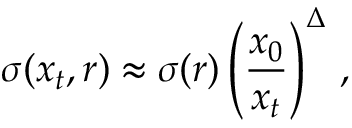<formula> <loc_0><loc_0><loc_500><loc_500>\sigma ( x _ { t } , r ) \approx \sigma ( r ) \left ( { \frac { x _ { 0 } } { x _ { t } } } \right ) ^ { \Delta } \, ,</formula> 